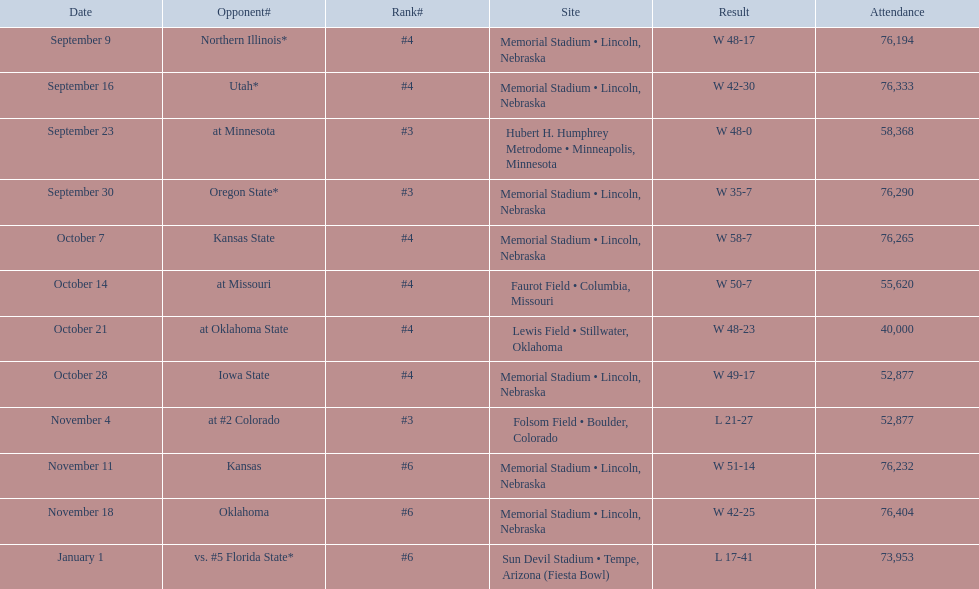When did nebraska participate in a game with oregon state? September 30. What was the crowd size at the september 30 event? 76,290. 